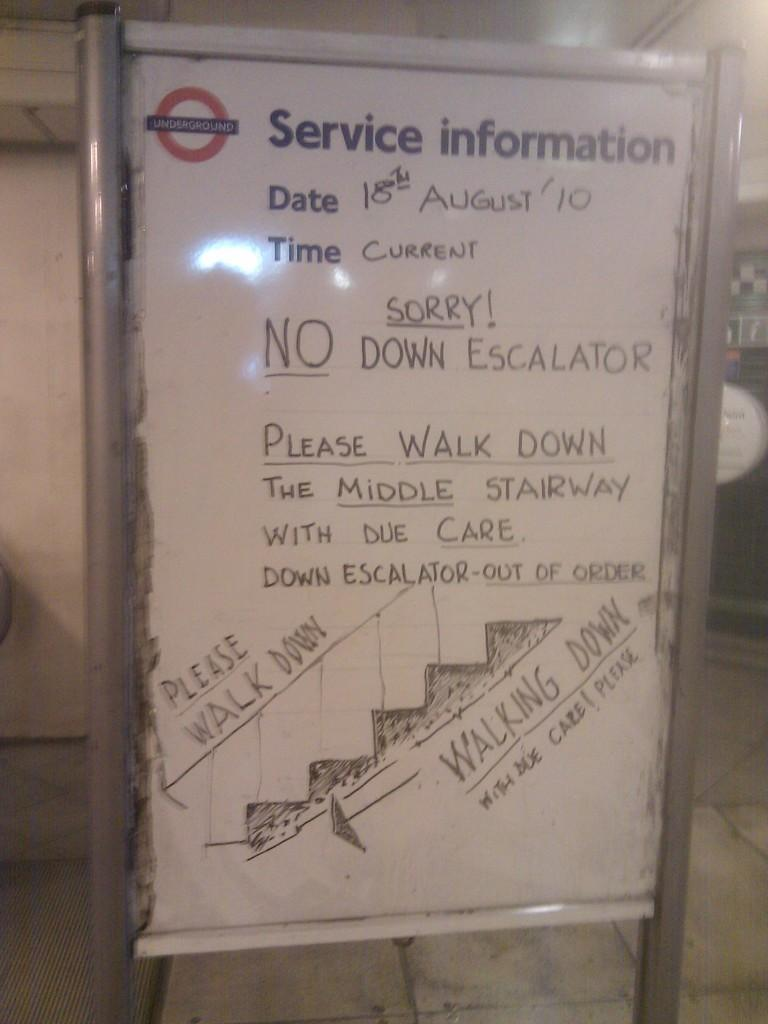<image>
Give a short and clear explanation of the subsequent image. A sign giving service information says there is no down escalator. 